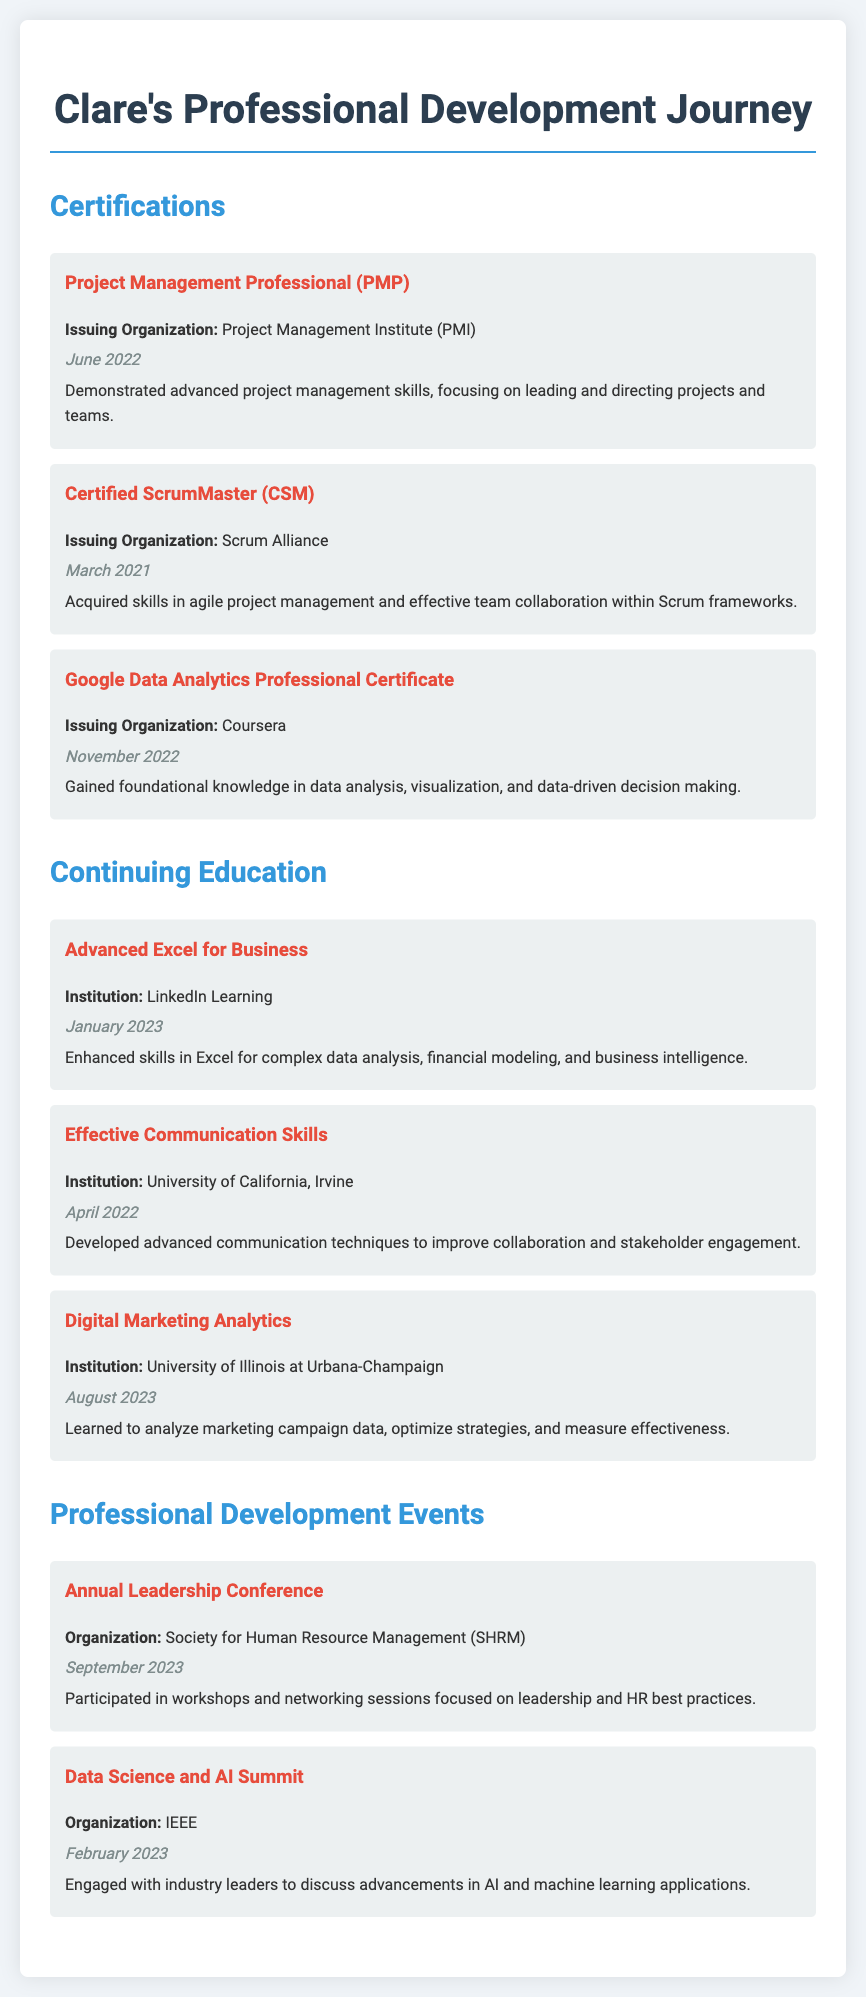what certification did Clare obtain from PMI? Clare obtained the Project Management Professional (PMP) certification from the Project Management Institute (PMI).
Answer: Project Management Professional (PMP) when did Clare complete the Certified ScrumMaster certification? Clare's Certified ScrumMaster certification was completed in March 2021.
Answer: March 2021 what institution offered the Digital Marketing Analytics course? The Digital Marketing Analytics course was offered by the University of Illinois at Urbana-Champaign.
Answer: University of Illinois at Urbana-Champaign how many certifications are listed under Clare's Professional Development? There are three certifications listed under Clare's Professional Development section.
Answer: Three what concept was a focus of Clare's Advanced Excel for Business training? Clare's Advanced Excel for Business training focused on complex data analysis.
Answer: complex data analysis which event did Clare participate in on September 2023? Clare participated in the Annual Leadership Conference organized by the Society for Human Resource Management (SHRM) on September 2023.
Answer: Annual Leadership Conference what skill did Clare aim to improve from the Effective Communication Skills course? Clare aimed to improve advanced communication techniques to enhance collaboration and stakeholder engagement.
Answer: advanced communication techniques how many continuing education courses did Clare take? Clare took three continuing education courses.
Answer: Three 